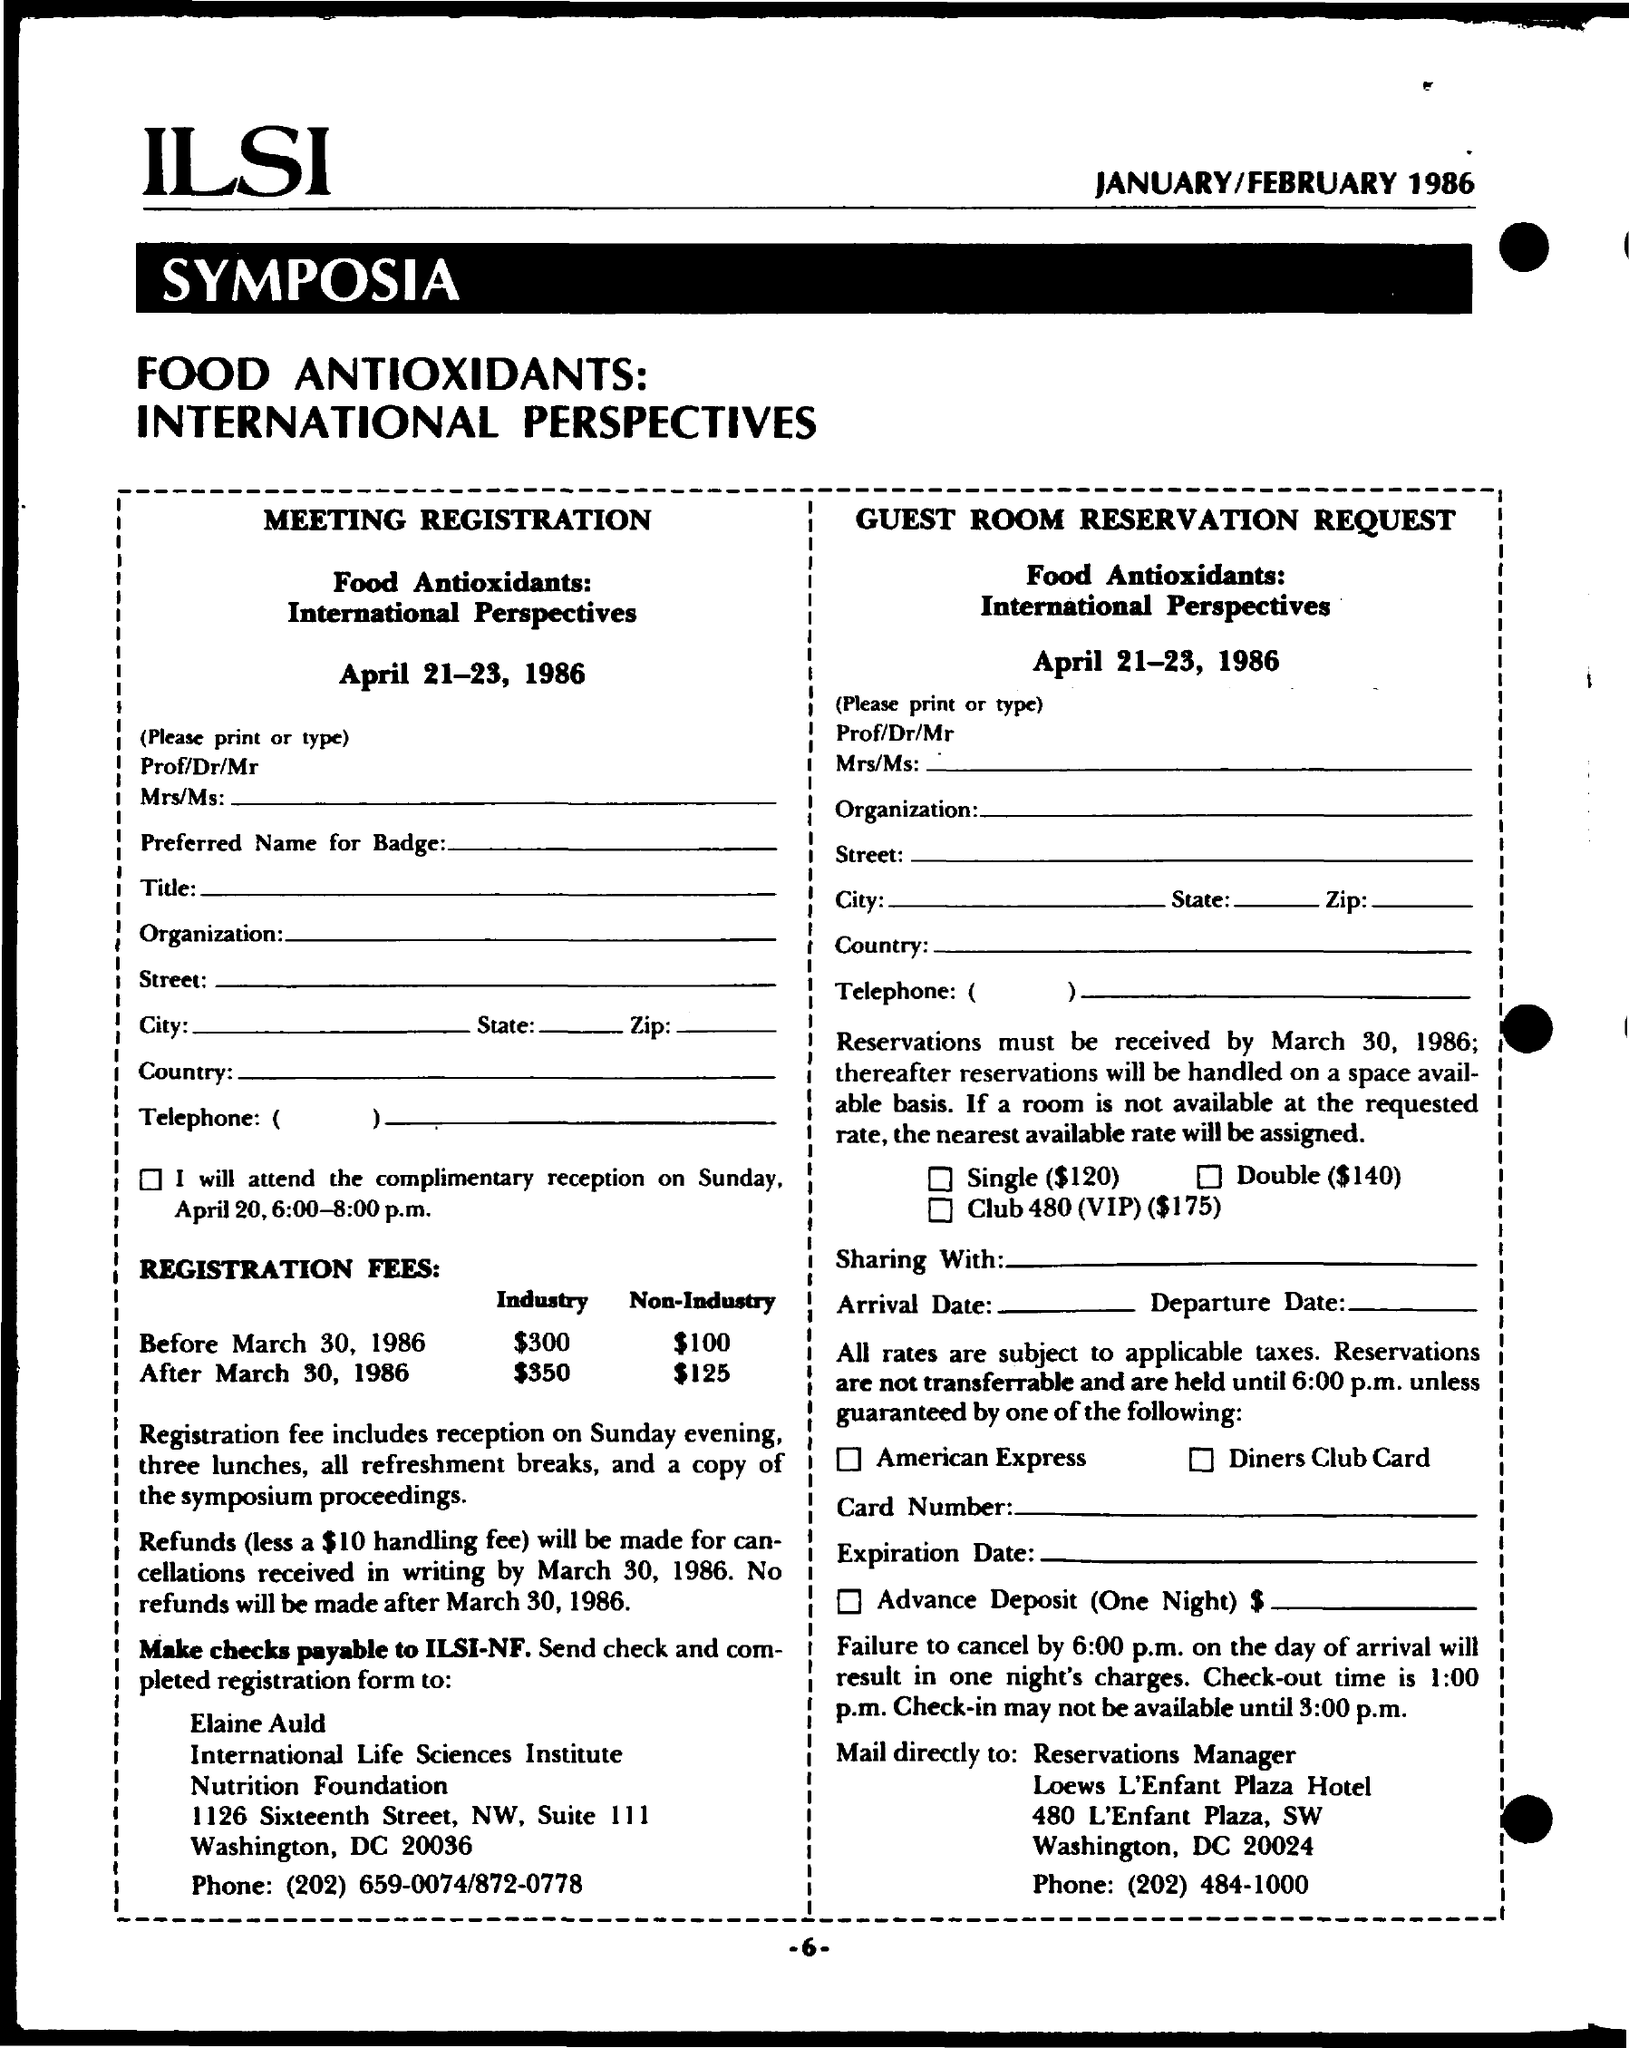What is the page number on this document?
Make the answer very short. -6-. 